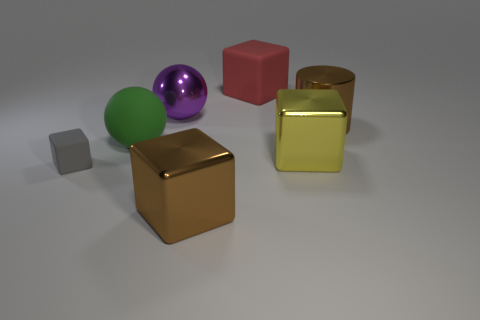Subtract all small cubes. How many cubes are left? 3 Subtract 1 cylinders. How many cylinders are left? 0 Subtract all green balls. How many balls are left? 1 Subtract all cylinders. How many objects are left? 6 Add 1 tiny purple rubber spheres. How many objects exist? 8 Add 1 yellow metallic things. How many yellow metallic things are left? 2 Add 5 large green balls. How many large green balls exist? 6 Subtract 0 blue blocks. How many objects are left? 7 Subtract all blue blocks. Subtract all red spheres. How many blocks are left? 4 Subtract all cyan balls. How many gray cubes are left? 1 